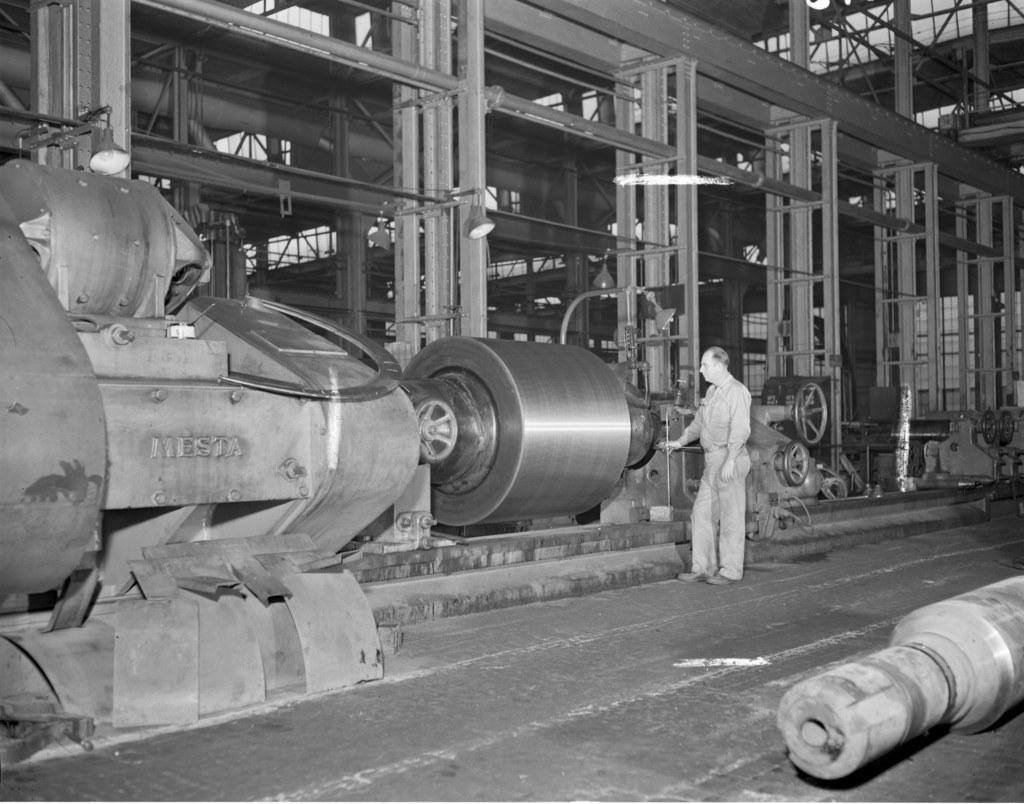Who or what is present in the image? There is a person in the image. Where is the person located? The person is standing in a factory. What is the color scheme of the image? The image is black and white. What type of discovery was made in the factory in the image? There is no indication of a discovery being made in the image; it simply shows a person standing in a factory. What time is it according to the watch in the image? There is no watch present in the image. 